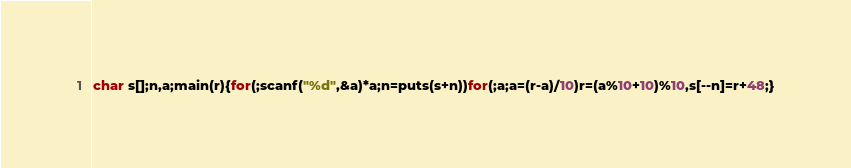<code> <loc_0><loc_0><loc_500><loc_500><_C_>char s[];n,a;main(r){for(;scanf("%d",&a)*a;n=puts(s+n))for(;a;a=(r-a)/10)r=(a%10+10)%10,s[--n]=r+48;}</code> 